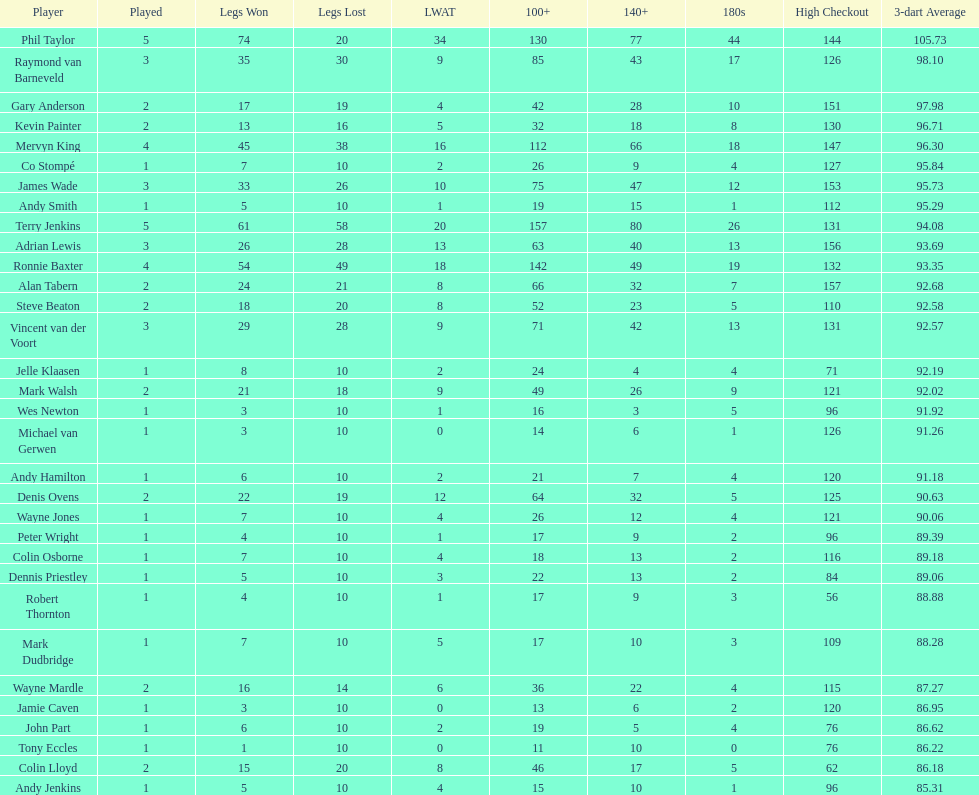Can you provide the count of legs that james wade lost? 26. 